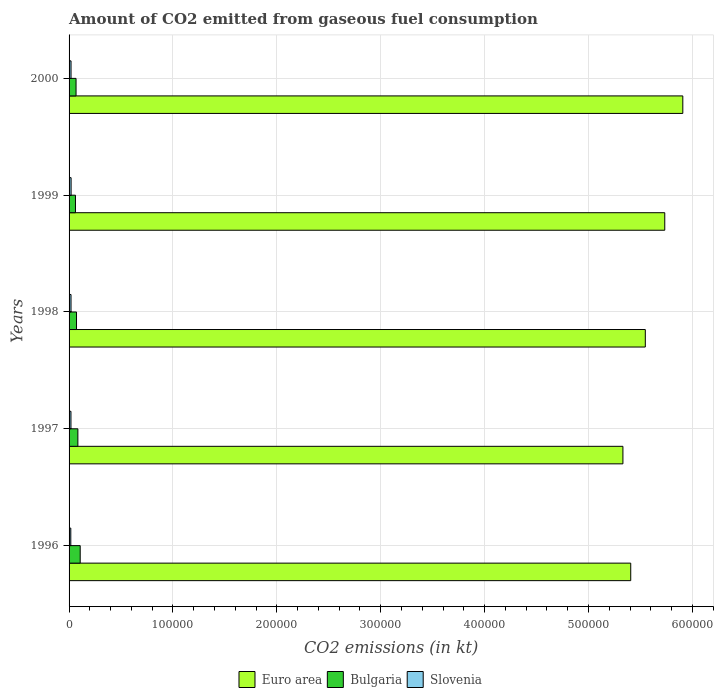How many groups of bars are there?
Give a very brief answer. 5. Are the number of bars per tick equal to the number of legend labels?
Your answer should be very brief. Yes. Are the number of bars on each tick of the Y-axis equal?
Your answer should be compact. Yes. In how many cases, is the number of bars for a given year not equal to the number of legend labels?
Make the answer very short. 0. What is the amount of CO2 emitted in Euro area in 2000?
Offer a very short reply. 5.91e+05. Across all years, what is the maximum amount of CO2 emitted in Bulgaria?
Make the answer very short. 1.07e+04. Across all years, what is the minimum amount of CO2 emitted in Euro area?
Your response must be concise. 5.33e+05. In which year was the amount of CO2 emitted in Slovenia minimum?
Make the answer very short. 1996. What is the total amount of CO2 emitted in Euro area in the graph?
Keep it short and to the point. 2.79e+06. What is the difference between the amount of CO2 emitted in Euro area in 1996 and that in 1999?
Keep it short and to the point. -3.27e+04. What is the difference between the amount of CO2 emitted in Slovenia in 1996 and the amount of CO2 emitted in Euro area in 1998?
Your answer should be very brief. -5.53e+05. What is the average amount of CO2 emitted in Bulgaria per year?
Offer a very short reply. 7843.71. In the year 1998, what is the difference between the amount of CO2 emitted in Slovenia and amount of CO2 emitted in Euro area?
Your answer should be very brief. -5.53e+05. In how many years, is the amount of CO2 emitted in Slovenia greater than 480000 kt?
Your answer should be very brief. 0. What is the ratio of the amount of CO2 emitted in Bulgaria in 1997 to that in 2000?
Your answer should be very brief. 1.26. Is the amount of CO2 emitted in Slovenia in 1997 less than that in 2000?
Ensure brevity in your answer.  Yes. What is the difference between the highest and the second highest amount of CO2 emitted in Bulgaria?
Make the answer very short. 2236.87. What is the difference between the highest and the lowest amount of CO2 emitted in Bulgaria?
Make the answer very short. 4558.08. In how many years, is the amount of CO2 emitted in Euro area greater than the average amount of CO2 emitted in Euro area taken over all years?
Keep it short and to the point. 2. What does the 2nd bar from the top in 1999 represents?
Give a very brief answer. Bulgaria. What does the 3rd bar from the bottom in 1998 represents?
Provide a succinct answer. Slovenia. Is it the case that in every year, the sum of the amount of CO2 emitted in Euro area and amount of CO2 emitted in Slovenia is greater than the amount of CO2 emitted in Bulgaria?
Offer a very short reply. Yes. How many bars are there?
Provide a short and direct response. 15. Are all the bars in the graph horizontal?
Offer a terse response. Yes. How many years are there in the graph?
Ensure brevity in your answer.  5. Does the graph contain any zero values?
Your answer should be very brief. No. Does the graph contain grids?
Offer a terse response. Yes. Where does the legend appear in the graph?
Provide a short and direct response. Bottom center. How are the legend labels stacked?
Ensure brevity in your answer.  Horizontal. What is the title of the graph?
Your answer should be compact. Amount of CO2 emitted from gaseous fuel consumption. Does "Botswana" appear as one of the legend labels in the graph?
Provide a short and direct response. No. What is the label or title of the X-axis?
Give a very brief answer. CO2 emissions (in kt). What is the CO2 emissions (in kt) of Euro area in 1996?
Ensure brevity in your answer.  5.41e+05. What is the CO2 emissions (in kt) in Bulgaria in 1996?
Give a very brief answer. 1.07e+04. What is the CO2 emissions (in kt) of Slovenia in 1996?
Give a very brief answer. 1668.48. What is the CO2 emissions (in kt) in Euro area in 1997?
Offer a terse response. 5.33e+05. What is the CO2 emissions (in kt) in Bulgaria in 1997?
Provide a short and direct response. 8474.44. What is the CO2 emissions (in kt) in Slovenia in 1997?
Offer a terse response. 1818.83. What is the CO2 emissions (in kt) in Euro area in 1998?
Provide a succinct answer. 5.55e+05. What is the CO2 emissions (in kt) of Bulgaria in 1998?
Provide a short and direct response. 7165.32. What is the CO2 emissions (in kt) of Slovenia in 1998?
Your answer should be very brief. 1877.5. What is the CO2 emissions (in kt) in Euro area in 1999?
Offer a very short reply. 5.73e+05. What is the CO2 emissions (in kt) of Bulgaria in 1999?
Your answer should be compact. 6153.23. What is the CO2 emissions (in kt) of Slovenia in 1999?
Your response must be concise. 1954.51. What is the CO2 emissions (in kt) in Euro area in 2000?
Ensure brevity in your answer.  5.91e+05. What is the CO2 emissions (in kt) of Bulgaria in 2000?
Offer a terse response. 6714.28. What is the CO2 emissions (in kt) of Slovenia in 2000?
Keep it short and to the point. 1892.17. Across all years, what is the maximum CO2 emissions (in kt) of Euro area?
Provide a short and direct response. 5.91e+05. Across all years, what is the maximum CO2 emissions (in kt) of Bulgaria?
Offer a very short reply. 1.07e+04. Across all years, what is the maximum CO2 emissions (in kt) in Slovenia?
Offer a very short reply. 1954.51. Across all years, what is the minimum CO2 emissions (in kt) of Euro area?
Offer a very short reply. 5.33e+05. Across all years, what is the minimum CO2 emissions (in kt) in Bulgaria?
Your answer should be very brief. 6153.23. Across all years, what is the minimum CO2 emissions (in kt) in Slovenia?
Ensure brevity in your answer.  1668.48. What is the total CO2 emissions (in kt) in Euro area in the graph?
Make the answer very short. 2.79e+06. What is the total CO2 emissions (in kt) of Bulgaria in the graph?
Ensure brevity in your answer.  3.92e+04. What is the total CO2 emissions (in kt) in Slovenia in the graph?
Your response must be concise. 9211.5. What is the difference between the CO2 emissions (in kt) of Euro area in 1996 and that in 1997?
Your response must be concise. 7521.55. What is the difference between the CO2 emissions (in kt) of Bulgaria in 1996 and that in 1997?
Your answer should be very brief. 2236.87. What is the difference between the CO2 emissions (in kt) of Slovenia in 1996 and that in 1997?
Keep it short and to the point. -150.35. What is the difference between the CO2 emissions (in kt) of Euro area in 1996 and that in 1998?
Keep it short and to the point. -1.40e+04. What is the difference between the CO2 emissions (in kt) in Bulgaria in 1996 and that in 1998?
Ensure brevity in your answer.  3545.99. What is the difference between the CO2 emissions (in kt) in Slovenia in 1996 and that in 1998?
Offer a very short reply. -209.02. What is the difference between the CO2 emissions (in kt) in Euro area in 1996 and that in 1999?
Your response must be concise. -3.27e+04. What is the difference between the CO2 emissions (in kt) in Bulgaria in 1996 and that in 1999?
Make the answer very short. 4558.08. What is the difference between the CO2 emissions (in kt) in Slovenia in 1996 and that in 1999?
Keep it short and to the point. -286.03. What is the difference between the CO2 emissions (in kt) of Euro area in 1996 and that in 2000?
Keep it short and to the point. -5.01e+04. What is the difference between the CO2 emissions (in kt) in Bulgaria in 1996 and that in 2000?
Your response must be concise. 3997.03. What is the difference between the CO2 emissions (in kt) in Slovenia in 1996 and that in 2000?
Provide a succinct answer. -223.69. What is the difference between the CO2 emissions (in kt) of Euro area in 1997 and that in 1998?
Keep it short and to the point. -2.16e+04. What is the difference between the CO2 emissions (in kt) in Bulgaria in 1997 and that in 1998?
Give a very brief answer. 1309.12. What is the difference between the CO2 emissions (in kt) of Slovenia in 1997 and that in 1998?
Offer a terse response. -58.67. What is the difference between the CO2 emissions (in kt) of Euro area in 1997 and that in 1999?
Offer a terse response. -4.03e+04. What is the difference between the CO2 emissions (in kt) of Bulgaria in 1997 and that in 1999?
Your response must be concise. 2321.21. What is the difference between the CO2 emissions (in kt) of Slovenia in 1997 and that in 1999?
Offer a terse response. -135.68. What is the difference between the CO2 emissions (in kt) of Euro area in 1997 and that in 2000?
Keep it short and to the point. -5.76e+04. What is the difference between the CO2 emissions (in kt) of Bulgaria in 1997 and that in 2000?
Your answer should be very brief. 1760.16. What is the difference between the CO2 emissions (in kt) of Slovenia in 1997 and that in 2000?
Provide a succinct answer. -73.34. What is the difference between the CO2 emissions (in kt) in Euro area in 1998 and that in 1999?
Give a very brief answer. -1.87e+04. What is the difference between the CO2 emissions (in kt) of Bulgaria in 1998 and that in 1999?
Offer a terse response. 1012.09. What is the difference between the CO2 emissions (in kt) of Slovenia in 1998 and that in 1999?
Offer a very short reply. -77.01. What is the difference between the CO2 emissions (in kt) of Euro area in 1998 and that in 2000?
Offer a very short reply. -3.61e+04. What is the difference between the CO2 emissions (in kt) in Bulgaria in 1998 and that in 2000?
Provide a succinct answer. 451.04. What is the difference between the CO2 emissions (in kt) of Slovenia in 1998 and that in 2000?
Provide a succinct answer. -14.67. What is the difference between the CO2 emissions (in kt) in Euro area in 1999 and that in 2000?
Offer a very short reply. -1.74e+04. What is the difference between the CO2 emissions (in kt) in Bulgaria in 1999 and that in 2000?
Your answer should be very brief. -561.05. What is the difference between the CO2 emissions (in kt) of Slovenia in 1999 and that in 2000?
Offer a terse response. 62.34. What is the difference between the CO2 emissions (in kt) of Euro area in 1996 and the CO2 emissions (in kt) of Bulgaria in 1997?
Provide a short and direct response. 5.32e+05. What is the difference between the CO2 emissions (in kt) in Euro area in 1996 and the CO2 emissions (in kt) in Slovenia in 1997?
Offer a terse response. 5.39e+05. What is the difference between the CO2 emissions (in kt) of Bulgaria in 1996 and the CO2 emissions (in kt) of Slovenia in 1997?
Provide a short and direct response. 8892.48. What is the difference between the CO2 emissions (in kt) in Euro area in 1996 and the CO2 emissions (in kt) in Bulgaria in 1998?
Your answer should be very brief. 5.33e+05. What is the difference between the CO2 emissions (in kt) of Euro area in 1996 and the CO2 emissions (in kt) of Slovenia in 1998?
Give a very brief answer. 5.39e+05. What is the difference between the CO2 emissions (in kt) in Bulgaria in 1996 and the CO2 emissions (in kt) in Slovenia in 1998?
Make the answer very short. 8833.8. What is the difference between the CO2 emissions (in kt) in Euro area in 1996 and the CO2 emissions (in kt) in Bulgaria in 1999?
Offer a terse response. 5.34e+05. What is the difference between the CO2 emissions (in kt) in Euro area in 1996 and the CO2 emissions (in kt) in Slovenia in 1999?
Your response must be concise. 5.39e+05. What is the difference between the CO2 emissions (in kt) in Bulgaria in 1996 and the CO2 emissions (in kt) in Slovenia in 1999?
Your response must be concise. 8756.8. What is the difference between the CO2 emissions (in kt) of Euro area in 1996 and the CO2 emissions (in kt) of Bulgaria in 2000?
Offer a terse response. 5.34e+05. What is the difference between the CO2 emissions (in kt) of Euro area in 1996 and the CO2 emissions (in kt) of Slovenia in 2000?
Your answer should be very brief. 5.39e+05. What is the difference between the CO2 emissions (in kt) in Bulgaria in 1996 and the CO2 emissions (in kt) in Slovenia in 2000?
Make the answer very short. 8819.14. What is the difference between the CO2 emissions (in kt) of Euro area in 1997 and the CO2 emissions (in kt) of Bulgaria in 1998?
Keep it short and to the point. 5.26e+05. What is the difference between the CO2 emissions (in kt) of Euro area in 1997 and the CO2 emissions (in kt) of Slovenia in 1998?
Offer a very short reply. 5.31e+05. What is the difference between the CO2 emissions (in kt) of Bulgaria in 1997 and the CO2 emissions (in kt) of Slovenia in 1998?
Your answer should be very brief. 6596.93. What is the difference between the CO2 emissions (in kt) of Euro area in 1997 and the CO2 emissions (in kt) of Bulgaria in 1999?
Your response must be concise. 5.27e+05. What is the difference between the CO2 emissions (in kt) in Euro area in 1997 and the CO2 emissions (in kt) in Slovenia in 1999?
Provide a short and direct response. 5.31e+05. What is the difference between the CO2 emissions (in kt) in Bulgaria in 1997 and the CO2 emissions (in kt) in Slovenia in 1999?
Keep it short and to the point. 6519.93. What is the difference between the CO2 emissions (in kt) in Euro area in 1997 and the CO2 emissions (in kt) in Bulgaria in 2000?
Your response must be concise. 5.26e+05. What is the difference between the CO2 emissions (in kt) in Euro area in 1997 and the CO2 emissions (in kt) in Slovenia in 2000?
Ensure brevity in your answer.  5.31e+05. What is the difference between the CO2 emissions (in kt) in Bulgaria in 1997 and the CO2 emissions (in kt) in Slovenia in 2000?
Ensure brevity in your answer.  6582.27. What is the difference between the CO2 emissions (in kt) of Euro area in 1998 and the CO2 emissions (in kt) of Bulgaria in 1999?
Your answer should be compact. 5.48e+05. What is the difference between the CO2 emissions (in kt) in Euro area in 1998 and the CO2 emissions (in kt) in Slovenia in 1999?
Provide a short and direct response. 5.53e+05. What is the difference between the CO2 emissions (in kt) in Bulgaria in 1998 and the CO2 emissions (in kt) in Slovenia in 1999?
Your answer should be very brief. 5210.81. What is the difference between the CO2 emissions (in kt) in Euro area in 1998 and the CO2 emissions (in kt) in Bulgaria in 2000?
Your answer should be compact. 5.48e+05. What is the difference between the CO2 emissions (in kt) of Euro area in 1998 and the CO2 emissions (in kt) of Slovenia in 2000?
Offer a very short reply. 5.53e+05. What is the difference between the CO2 emissions (in kt) in Bulgaria in 1998 and the CO2 emissions (in kt) in Slovenia in 2000?
Provide a succinct answer. 5273.15. What is the difference between the CO2 emissions (in kt) in Euro area in 1999 and the CO2 emissions (in kt) in Bulgaria in 2000?
Your answer should be compact. 5.67e+05. What is the difference between the CO2 emissions (in kt) in Euro area in 1999 and the CO2 emissions (in kt) in Slovenia in 2000?
Offer a very short reply. 5.71e+05. What is the difference between the CO2 emissions (in kt) in Bulgaria in 1999 and the CO2 emissions (in kt) in Slovenia in 2000?
Provide a succinct answer. 4261.05. What is the average CO2 emissions (in kt) of Euro area per year?
Keep it short and to the point. 5.58e+05. What is the average CO2 emissions (in kt) of Bulgaria per year?
Keep it short and to the point. 7843.71. What is the average CO2 emissions (in kt) of Slovenia per year?
Your response must be concise. 1842.3. In the year 1996, what is the difference between the CO2 emissions (in kt) of Euro area and CO2 emissions (in kt) of Bulgaria?
Ensure brevity in your answer.  5.30e+05. In the year 1996, what is the difference between the CO2 emissions (in kt) of Euro area and CO2 emissions (in kt) of Slovenia?
Your answer should be compact. 5.39e+05. In the year 1996, what is the difference between the CO2 emissions (in kt) in Bulgaria and CO2 emissions (in kt) in Slovenia?
Your answer should be very brief. 9042.82. In the year 1997, what is the difference between the CO2 emissions (in kt) of Euro area and CO2 emissions (in kt) of Bulgaria?
Offer a very short reply. 5.25e+05. In the year 1997, what is the difference between the CO2 emissions (in kt) in Euro area and CO2 emissions (in kt) in Slovenia?
Your response must be concise. 5.31e+05. In the year 1997, what is the difference between the CO2 emissions (in kt) of Bulgaria and CO2 emissions (in kt) of Slovenia?
Provide a short and direct response. 6655.6. In the year 1998, what is the difference between the CO2 emissions (in kt) in Euro area and CO2 emissions (in kt) in Bulgaria?
Make the answer very short. 5.47e+05. In the year 1998, what is the difference between the CO2 emissions (in kt) in Euro area and CO2 emissions (in kt) in Slovenia?
Ensure brevity in your answer.  5.53e+05. In the year 1998, what is the difference between the CO2 emissions (in kt) of Bulgaria and CO2 emissions (in kt) of Slovenia?
Ensure brevity in your answer.  5287.81. In the year 1999, what is the difference between the CO2 emissions (in kt) of Euro area and CO2 emissions (in kt) of Bulgaria?
Ensure brevity in your answer.  5.67e+05. In the year 1999, what is the difference between the CO2 emissions (in kt) of Euro area and CO2 emissions (in kt) of Slovenia?
Ensure brevity in your answer.  5.71e+05. In the year 1999, what is the difference between the CO2 emissions (in kt) in Bulgaria and CO2 emissions (in kt) in Slovenia?
Give a very brief answer. 4198.72. In the year 2000, what is the difference between the CO2 emissions (in kt) in Euro area and CO2 emissions (in kt) in Bulgaria?
Your answer should be very brief. 5.84e+05. In the year 2000, what is the difference between the CO2 emissions (in kt) of Euro area and CO2 emissions (in kt) of Slovenia?
Provide a short and direct response. 5.89e+05. In the year 2000, what is the difference between the CO2 emissions (in kt) of Bulgaria and CO2 emissions (in kt) of Slovenia?
Offer a terse response. 4822.1. What is the ratio of the CO2 emissions (in kt) of Euro area in 1996 to that in 1997?
Keep it short and to the point. 1.01. What is the ratio of the CO2 emissions (in kt) in Bulgaria in 1996 to that in 1997?
Give a very brief answer. 1.26. What is the ratio of the CO2 emissions (in kt) of Slovenia in 1996 to that in 1997?
Offer a very short reply. 0.92. What is the ratio of the CO2 emissions (in kt) in Euro area in 1996 to that in 1998?
Provide a short and direct response. 0.97. What is the ratio of the CO2 emissions (in kt) in Bulgaria in 1996 to that in 1998?
Offer a terse response. 1.49. What is the ratio of the CO2 emissions (in kt) of Slovenia in 1996 to that in 1998?
Offer a terse response. 0.89. What is the ratio of the CO2 emissions (in kt) in Euro area in 1996 to that in 1999?
Provide a short and direct response. 0.94. What is the ratio of the CO2 emissions (in kt) in Bulgaria in 1996 to that in 1999?
Make the answer very short. 1.74. What is the ratio of the CO2 emissions (in kt) of Slovenia in 1996 to that in 1999?
Ensure brevity in your answer.  0.85. What is the ratio of the CO2 emissions (in kt) in Euro area in 1996 to that in 2000?
Make the answer very short. 0.92. What is the ratio of the CO2 emissions (in kt) of Bulgaria in 1996 to that in 2000?
Give a very brief answer. 1.6. What is the ratio of the CO2 emissions (in kt) in Slovenia in 1996 to that in 2000?
Provide a short and direct response. 0.88. What is the ratio of the CO2 emissions (in kt) in Euro area in 1997 to that in 1998?
Your answer should be compact. 0.96. What is the ratio of the CO2 emissions (in kt) in Bulgaria in 1997 to that in 1998?
Give a very brief answer. 1.18. What is the ratio of the CO2 emissions (in kt) in Slovenia in 1997 to that in 1998?
Make the answer very short. 0.97. What is the ratio of the CO2 emissions (in kt) of Euro area in 1997 to that in 1999?
Provide a short and direct response. 0.93. What is the ratio of the CO2 emissions (in kt) of Bulgaria in 1997 to that in 1999?
Offer a very short reply. 1.38. What is the ratio of the CO2 emissions (in kt) in Slovenia in 1997 to that in 1999?
Provide a succinct answer. 0.93. What is the ratio of the CO2 emissions (in kt) of Euro area in 1997 to that in 2000?
Offer a very short reply. 0.9. What is the ratio of the CO2 emissions (in kt) in Bulgaria in 1997 to that in 2000?
Your answer should be very brief. 1.26. What is the ratio of the CO2 emissions (in kt) in Slovenia in 1997 to that in 2000?
Your response must be concise. 0.96. What is the ratio of the CO2 emissions (in kt) of Euro area in 1998 to that in 1999?
Ensure brevity in your answer.  0.97. What is the ratio of the CO2 emissions (in kt) in Bulgaria in 1998 to that in 1999?
Your response must be concise. 1.16. What is the ratio of the CO2 emissions (in kt) of Slovenia in 1998 to that in 1999?
Provide a short and direct response. 0.96. What is the ratio of the CO2 emissions (in kt) of Euro area in 1998 to that in 2000?
Your answer should be very brief. 0.94. What is the ratio of the CO2 emissions (in kt) in Bulgaria in 1998 to that in 2000?
Keep it short and to the point. 1.07. What is the ratio of the CO2 emissions (in kt) in Euro area in 1999 to that in 2000?
Your answer should be compact. 0.97. What is the ratio of the CO2 emissions (in kt) of Bulgaria in 1999 to that in 2000?
Your answer should be very brief. 0.92. What is the ratio of the CO2 emissions (in kt) of Slovenia in 1999 to that in 2000?
Ensure brevity in your answer.  1.03. What is the difference between the highest and the second highest CO2 emissions (in kt) of Euro area?
Provide a succinct answer. 1.74e+04. What is the difference between the highest and the second highest CO2 emissions (in kt) in Bulgaria?
Your answer should be very brief. 2236.87. What is the difference between the highest and the second highest CO2 emissions (in kt) in Slovenia?
Make the answer very short. 62.34. What is the difference between the highest and the lowest CO2 emissions (in kt) in Euro area?
Offer a terse response. 5.76e+04. What is the difference between the highest and the lowest CO2 emissions (in kt) in Bulgaria?
Keep it short and to the point. 4558.08. What is the difference between the highest and the lowest CO2 emissions (in kt) in Slovenia?
Your answer should be very brief. 286.03. 